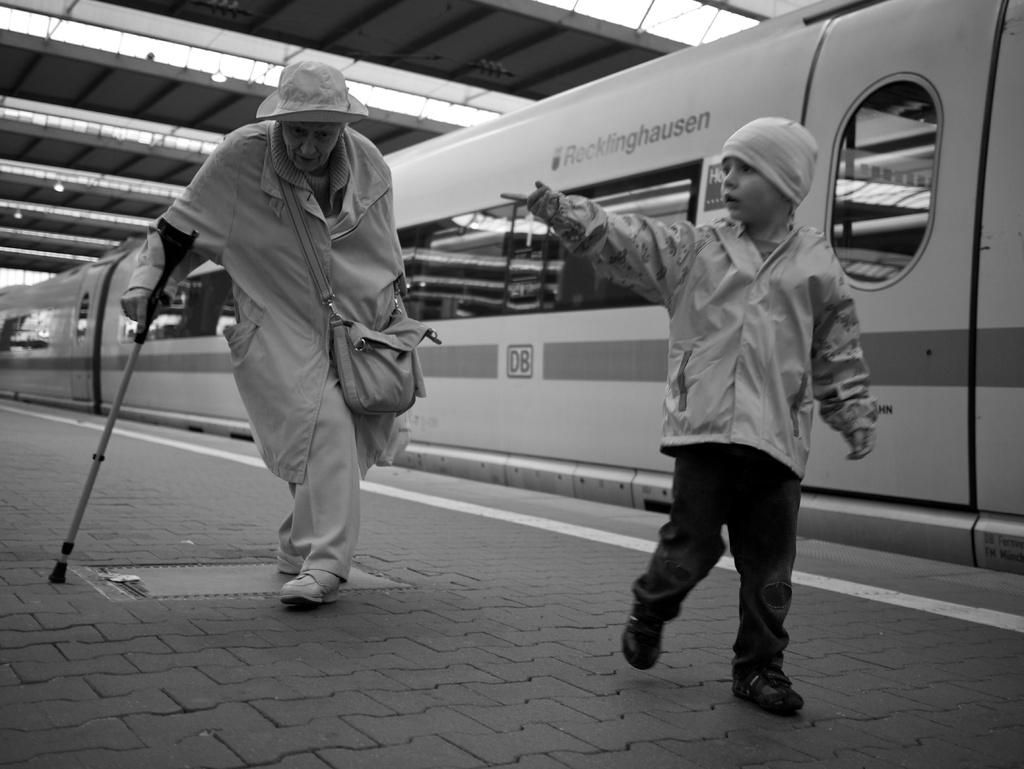<image>
Render a clear and concise summary of the photo. Two people are standing in front of a subway that was the word "Recklinghausen" painted to the side of it. 